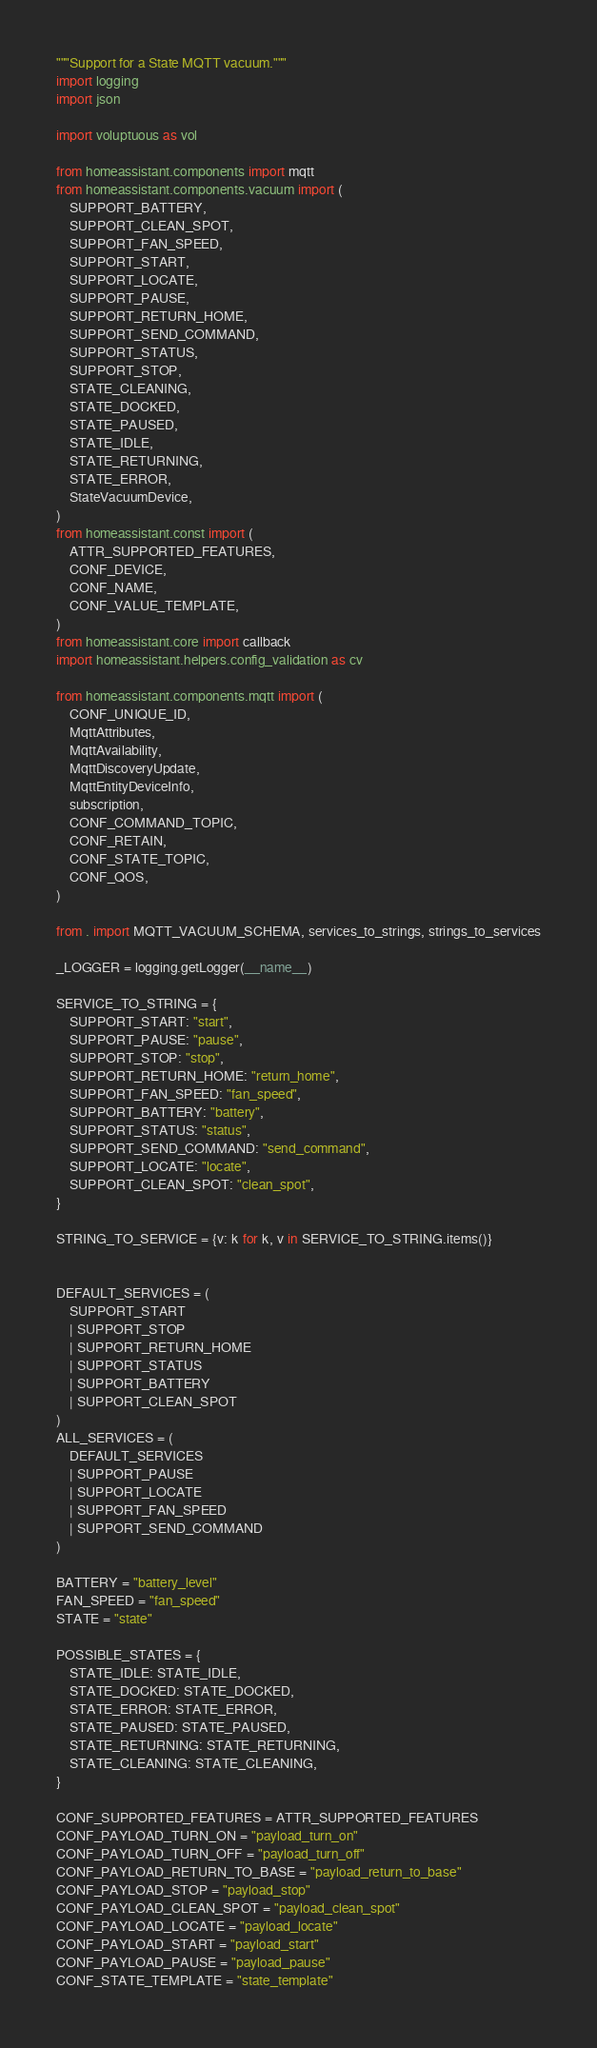<code> <loc_0><loc_0><loc_500><loc_500><_Python_>"""Support for a State MQTT vacuum."""
import logging
import json

import voluptuous as vol

from homeassistant.components import mqtt
from homeassistant.components.vacuum import (
    SUPPORT_BATTERY,
    SUPPORT_CLEAN_SPOT,
    SUPPORT_FAN_SPEED,
    SUPPORT_START,
    SUPPORT_LOCATE,
    SUPPORT_PAUSE,
    SUPPORT_RETURN_HOME,
    SUPPORT_SEND_COMMAND,
    SUPPORT_STATUS,
    SUPPORT_STOP,
    STATE_CLEANING,
    STATE_DOCKED,
    STATE_PAUSED,
    STATE_IDLE,
    STATE_RETURNING,
    STATE_ERROR,
    StateVacuumDevice,
)
from homeassistant.const import (
    ATTR_SUPPORTED_FEATURES,
    CONF_DEVICE,
    CONF_NAME,
    CONF_VALUE_TEMPLATE,
)
from homeassistant.core import callback
import homeassistant.helpers.config_validation as cv

from homeassistant.components.mqtt import (
    CONF_UNIQUE_ID,
    MqttAttributes,
    MqttAvailability,
    MqttDiscoveryUpdate,
    MqttEntityDeviceInfo,
    subscription,
    CONF_COMMAND_TOPIC,
    CONF_RETAIN,
    CONF_STATE_TOPIC,
    CONF_QOS,
)

from . import MQTT_VACUUM_SCHEMA, services_to_strings, strings_to_services

_LOGGER = logging.getLogger(__name__)

SERVICE_TO_STRING = {
    SUPPORT_START: "start",
    SUPPORT_PAUSE: "pause",
    SUPPORT_STOP: "stop",
    SUPPORT_RETURN_HOME: "return_home",
    SUPPORT_FAN_SPEED: "fan_speed",
    SUPPORT_BATTERY: "battery",
    SUPPORT_STATUS: "status",
    SUPPORT_SEND_COMMAND: "send_command",
    SUPPORT_LOCATE: "locate",
    SUPPORT_CLEAN_SPOT: "clean_spot",
}

STRING_TO_SERVICE = {v: k for k, v in SERVICE_TO_STRING.items()}


DEFAULT_SERVICES = (
    SUPPORT_START
    | SUPPORT_STOP
    | SUPPORT_RETURN_HOME
    | SUPPORT_STATUS
    | SUPPORT_BATTERY
    | SUPPORT_CLEAN_SPOT
)
ALL_SERVICES = (
    DEFAULT_SERVICES
    | SUPPORT_PAUSE
    | SUPPORT_LOCATE
    | SUPPORT_FAN_SPEED
    | SUPPORT_SEND_COMMAND
)

BATTERY = "battery_level"
FAN_SPEED = "fan_speed"
STATE = "state"

POSSIBLE_STATES = {
    STATE_IDLE: STATE_IDLE,
    STATE_DOCKED: STATE_DOCKED,
    STATE_ERROR: STATE_ERROR,
    STATE_PAUSED: STATE_PAUSED,
    STATE_RETURNING: STATE_RETURNING,
    STATE_CLEANING: STATE_CLEANING,
}

CONF_SUPPORTED_FEATURES = ATTR_SUPPORTED_FEATURES
CONF_PAYLOAD_TURN_ON = "payload_turn_on"
CONF_PAYLOAD_TURN_OFF = "payload_turn_off"
CONF_PAYLOAD_RETURN_TO_BASE = "payload_return_to_base"
CONF_PAYLOAD_STOP = "payload_stop"
CONF_PAYLOAD_CLEAN_SPOT = "payload_clean_spot"
CONF_PAYLOAD_LOCATE = "payload_locate"
CONF_PAYLOAD_START = "payload_start"
CONF_PAYLOAD_PAUSE = "payload_pause"
CONF_STATE_TEMPLATE = "state_template"</code> 